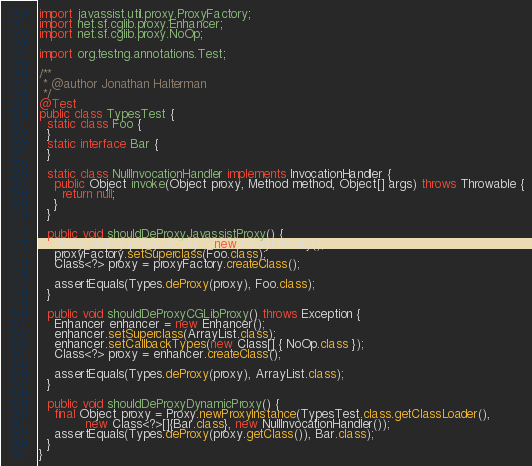<code> <loc_0><loc_0><loc_500><loc_500><_Java_>
import javassist.util.proxy.ProxyFactory;
import net.sf.cglib.proxy.Enhancer;
import net.sf.cglib.proxy.NoOp;

import org.testng.annotations.Test;

/**
 * @author Jonathan Halterman
 */
@Test
public class TypesTest {
  static class Foo {
  }
  static interface Bar {
  }

  static class NullInvocationHandler implements InvocationHandler {
    public Object invoke(Object proxy, Method method, Object[] args) throws Throwable {
      return null;
    }
  }

  public void shouldDeProxyJavassistProxy() {
    ProxyFactory proxyFactory = new ProxyFactory();
    proxyFactory.setSuperclass(Foo.class);
    Class<?> proxy = proxyFactory.createClass();

    assertEquals(Types.deProxy(proxy), Foo.class);
  }

  public void shouldDeProxyCGLibProxy() throws Exception {
    Enhancer enhancer = new Enhancer();
    enhancer.setSuperclass(ArrayList.class);
    enhancer.setCallbackTypes(new Class[] { NoOp.class });
    Class<?> proxy = enhancer.createClass();

    assertEquals(Types.deProxy(proxy), ArrayList.class);
  }

  public void shouldDeProxyDynamicProxy() {
    final Object proxy = Proxy.newProxyInstance(TypesTest.class.getClassLoader(),
            new Class<?>[]{Bar.class}, new NullInvocationHandler());
    assertEquals(Types.deProxy(proxy.getClass()), Bar.class);
  }
}
</code> 